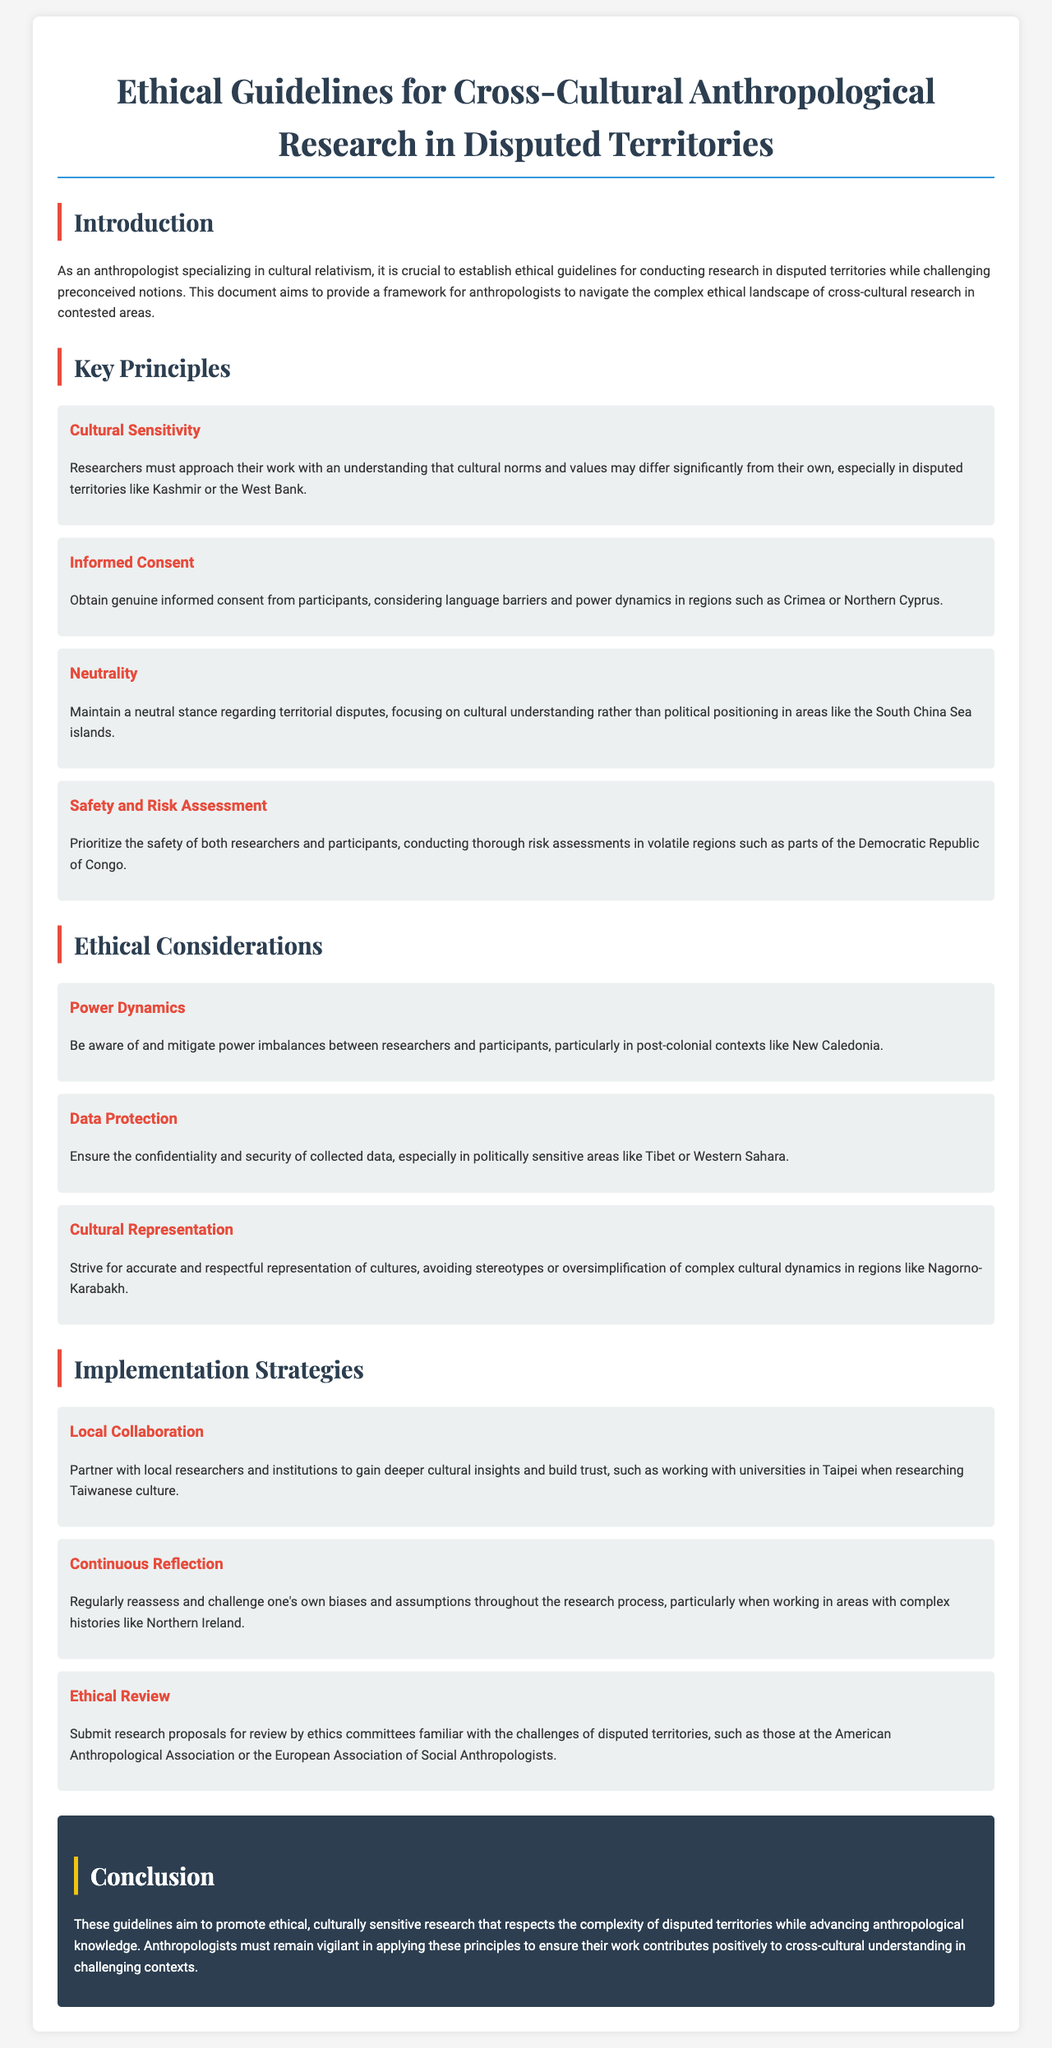what is the title of the document? The title appears in the header section of the document, describing the main focus of the guidelines.
Answer: Ethical Guidelines for Cross-Cultural Anthropological Research in Disputed Territories how many key principles are outlined? The document lists a total of four key principles within the Key Principles section.
Answer: 4 name one of the regions mentioned in relation to cultural sensitivity. The document provides examples of disputed territories in different sections, particularly under Cultural Sensitivity.
Answer: Kashmir what does the principle of neutrality emphasize? The principle of neutrality discusses an approach to research that avoids political positioning.
Answer: Cultural understanding what is a strategy for gaining cultural insights? The Implementation Strategies section outlines various ways researchers can enhance their studies, including collaboration.
Answer: Local Collaboration what should researchers regularly reassess according to Implementation Strategies? The document encourages researchers to reflect on their own perspectives throughout their work.
Answer: Biases and assumptions name a specific ethical consideration related to data. Within the Ethical Considerations section, there are specific guidelines for handling sensitive data.
Answer: Data Protection which organization should ethics committee proposals be submitted to? The document suggests specific organizations familiar with the unique challenges of research in disputed territories.
Answer: American Anthropological Association what is the conclusion aiming to promote? The Conclusion summarizes the overarching goal of the ethical guidelines discussed earlier in the document.
Answer: Ethical, culturally sensitive research 